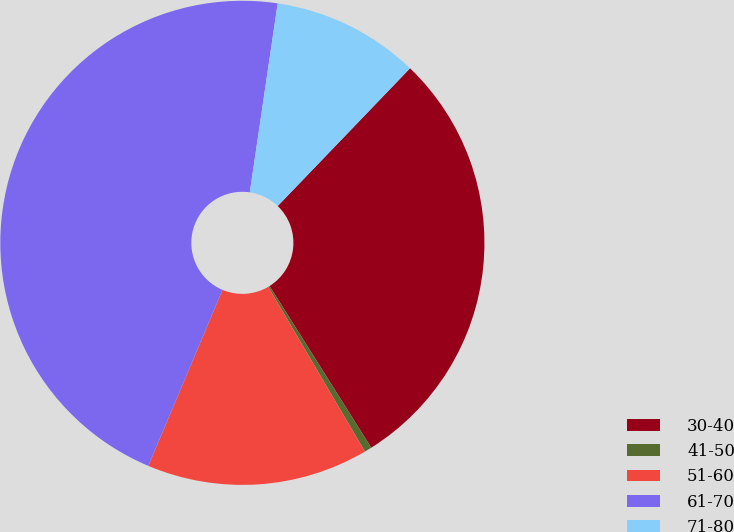Convert chart to OTSL. <chart><loc_0><loc_0><loc_500><loc_500><pie_chart><fcel>30-40<fcel>41-50<fcel>51-60<fcel>61-70<fcel>71-80<nl><fcel>28.88%<fcel>0.49%<fcel>14.8%<fcel>45.98%<fcel>9.85%<nl></chart> 